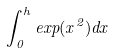Convert formula to latex. <formula><loc_0><loc_0><loc_500><loc_500>\int _ { 0 } ^ { h } e x p ( x ^ { 2 } ) d x</formula> 